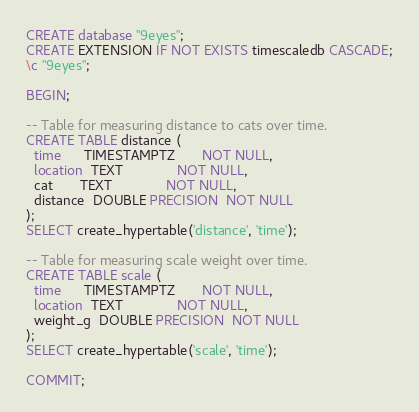Convert code to text. <code><loc_0><loc_0><loc_500><loc_500><_SQL_>CREATE database "9eyes";
CREATE EXTENSION IF NOT EXISTS timescaledb CASCADE;
\c "9eyes";

BEGIN;

-- Table for measuring distance to cats over time.
CREATE TABLE distance (
  time      TIMESTAMPTZ       NOT NULL,
  location  TEXT              NOT NULL,
  cat       TEXT              NOT NULL,
  distance  DOUBLE PRECISION  NOT NULL
);
SELECT create_hypertable('distance', 'time');

-- Table for measuring scale weight over time.
CREATE TABLE scale (
  time      TIMESTAMPTZ       NOT NULL,
  location  TEXT              NOT NULL,
  weight_g  DOUBLE PRECISION  NOT NULL
);
SELECT create_hypertable('scale', 'time');

COMMIT;
</code> 